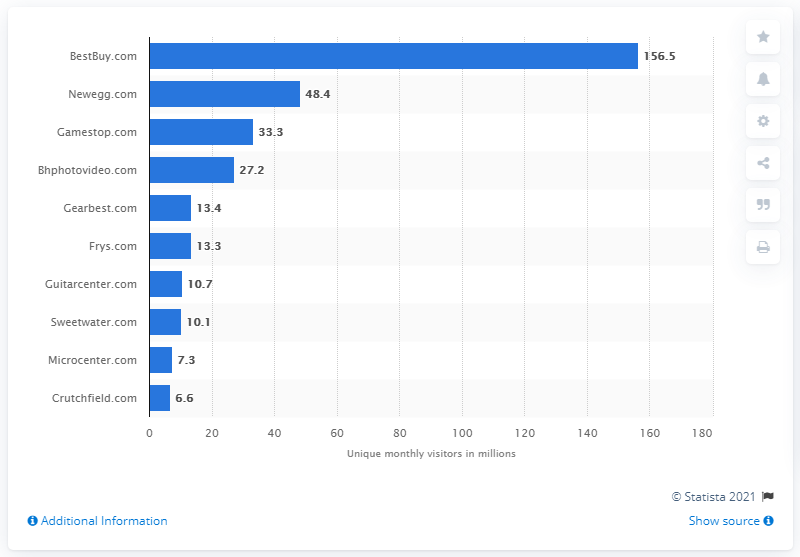Mention a couple of crucial points in this snapshot. During the measured period, BestBuy.com generated 156.5 visits. 